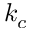<formula> <loc_0><loc_0><loc_500><loc_500>k _ { c }</formula> 